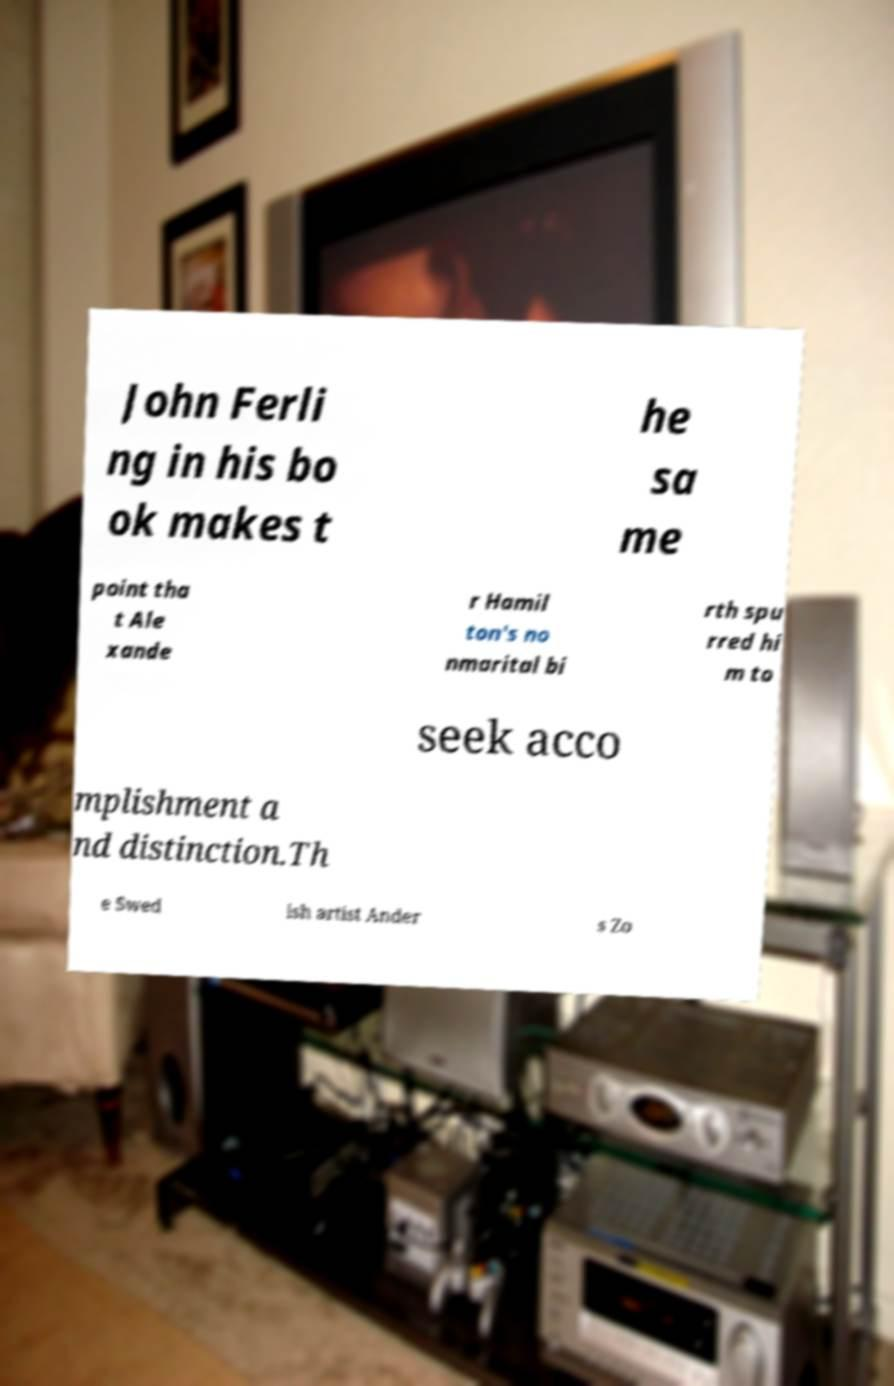There's text embedded in this image that I need extracted. Can you transcribe it verbatim? John Ferli ng in his bo ok makes t he sa me point tha t Ale xande r Hamil ton's no nmarital bi rth spu rred hi m to seek acco mplishment a nd distinction.Th e Swed ish artist Ander s Zo 